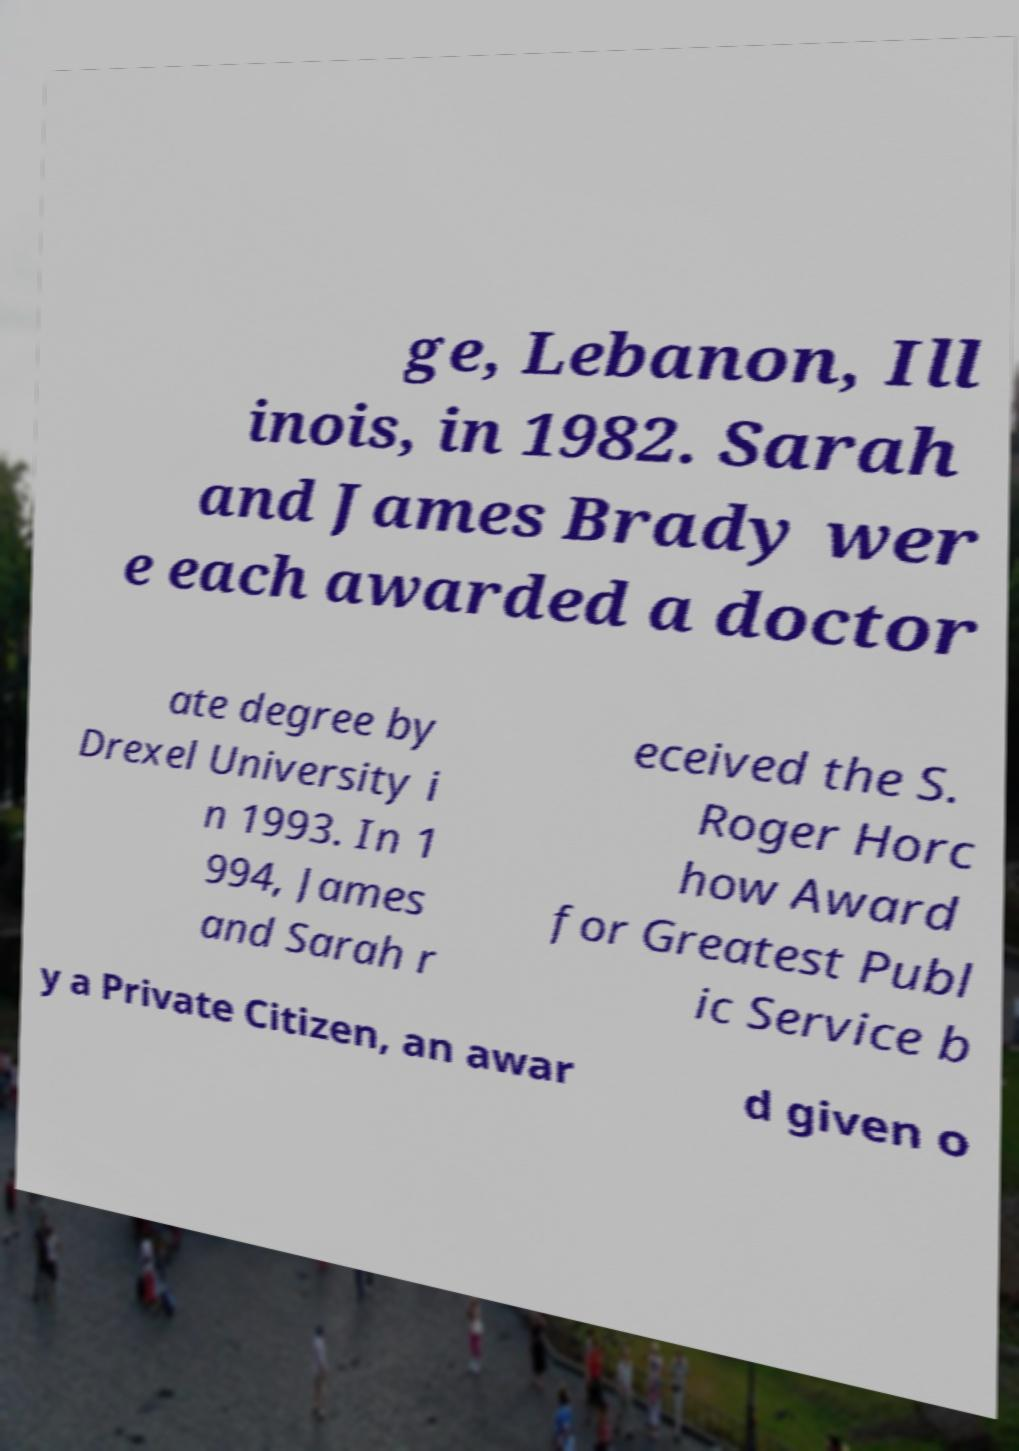Could you assist in decoding the text presented in this image and type it out clearly? ge, Lebanon, Ill inois, in 1982. Sarah and James Brady wer e each awarded a doctor ate degree by Drexel University i n 1993. In 1 994, James and Sarah r eceived the S. Roger Horc how Award for Greatest Publ ic Service b y a Private Citizen, an awar d given o 